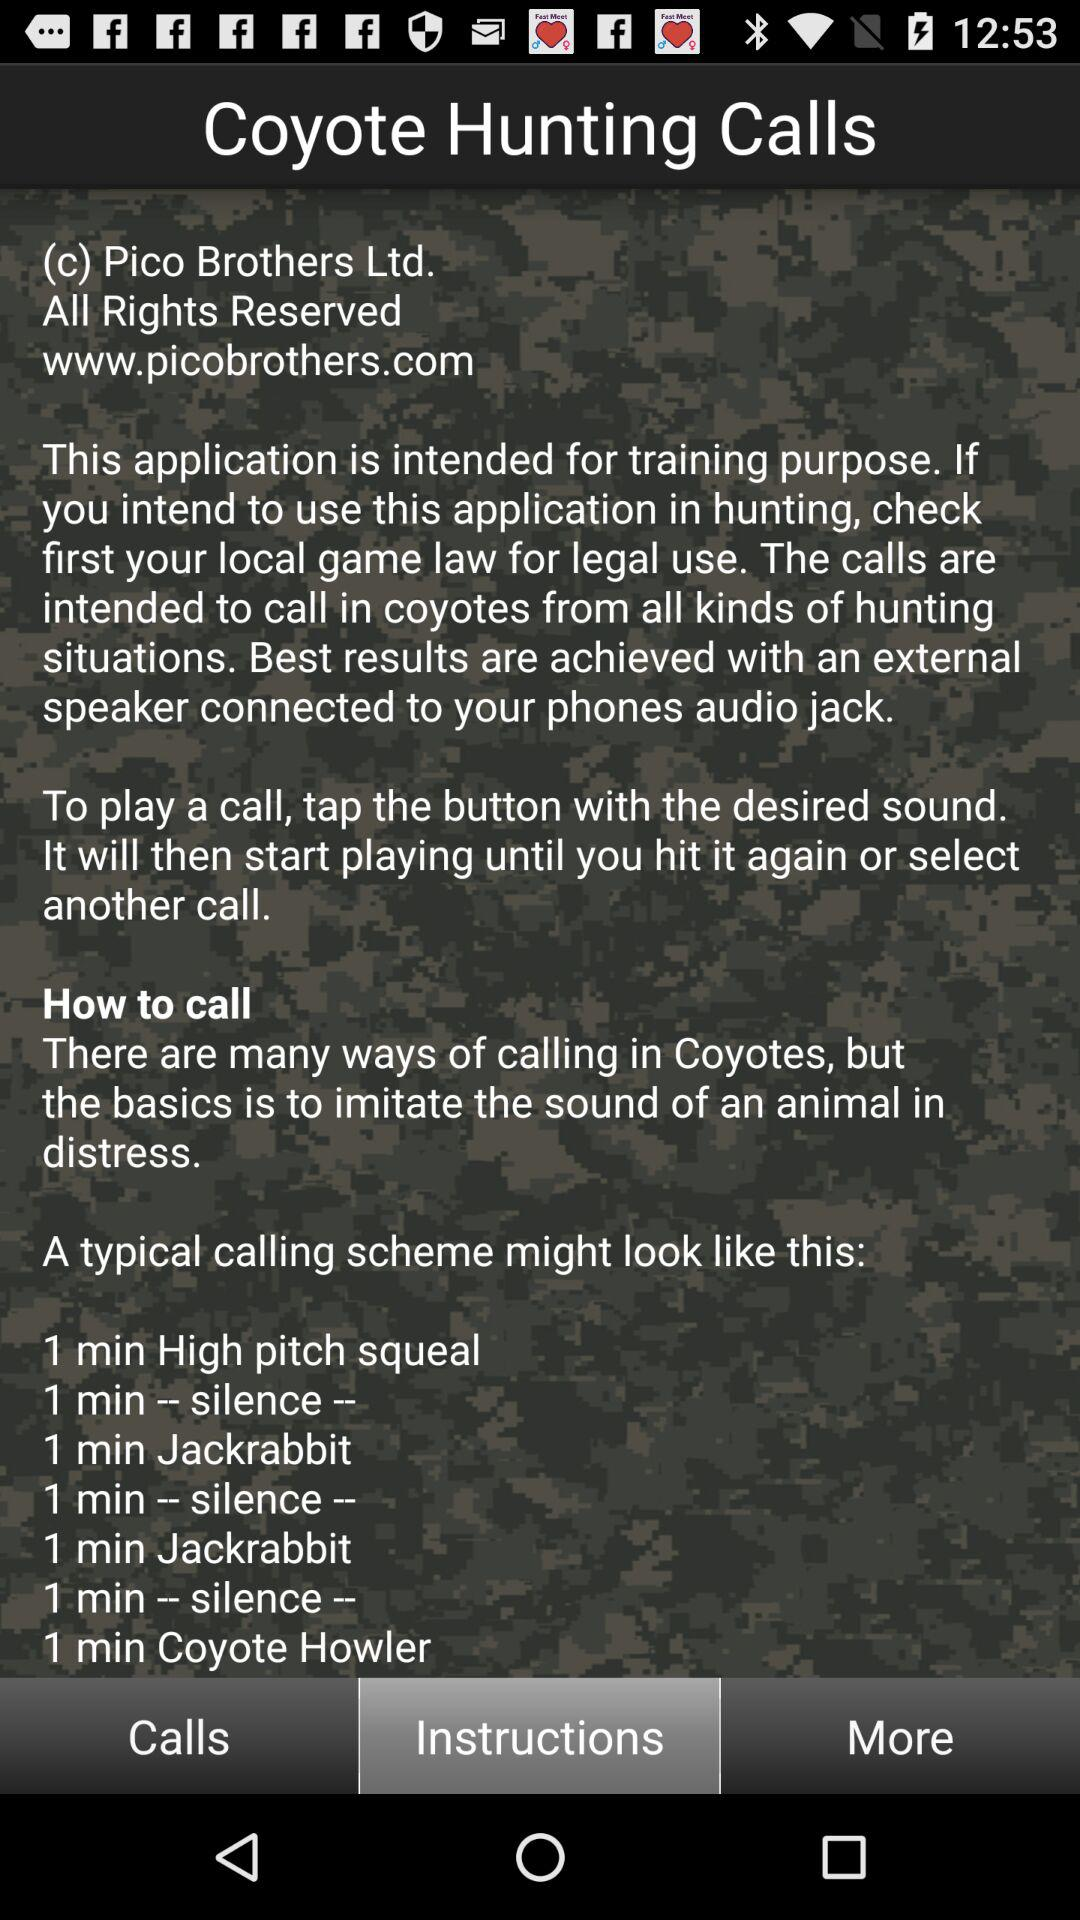How many times does the text "silence" appear in the instructions? The text 'silence' appears three times in the calling scheme instructions, highlighted under 'How to call' in the coyote hunting app. Each 'silence' interval is strategically used to help mimic a natural environment in hunting scenarios, enhancing the efficacy of the coyote calls. 